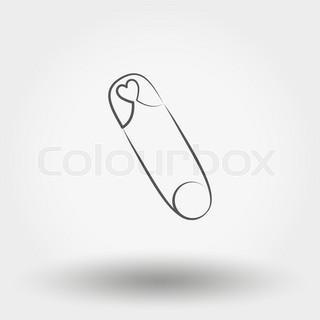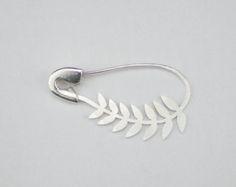The first image is the image on the left, the second image is the image on the right. Considering the images on both sides, is "There are four safety pins." valid? Answer yes or no. No. The first image is the image on the left, the second image is the image on the right. For the images shown, is this caption "There's at least one open safety pin." true? Answer yes or no. No. 